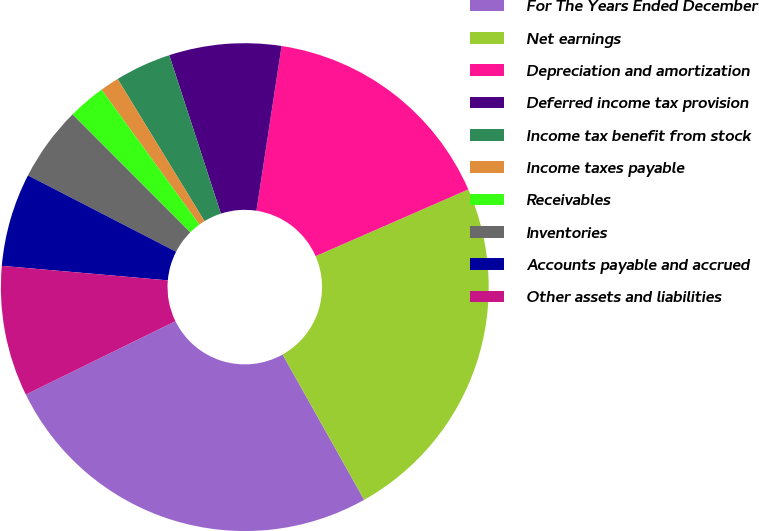Convert chart. <chart><loc_0><loc_0><loc_500><loc_500><pie_chart><fcel>For The Years Ended December<fcel>Net earnings<fcel>Depreciation and amortization<fcel>Deferred income tax provision<fcel>Income tax benefit from stock<fcel>Income taxes payable<fcel>Receivables<fcel>Inventories<fcel>Accounts payable and accrued<fcel>Other assets and liabilities<nl><fcel>25.88%<fcel>23.42%<fcel>16.03%<fcel>7.42%<fcel>3.72%<fcel>1.26%<fcel>2.49%<fcel>4.95%<fcel>6.18%<fcel>8.65%<nl></chart> 